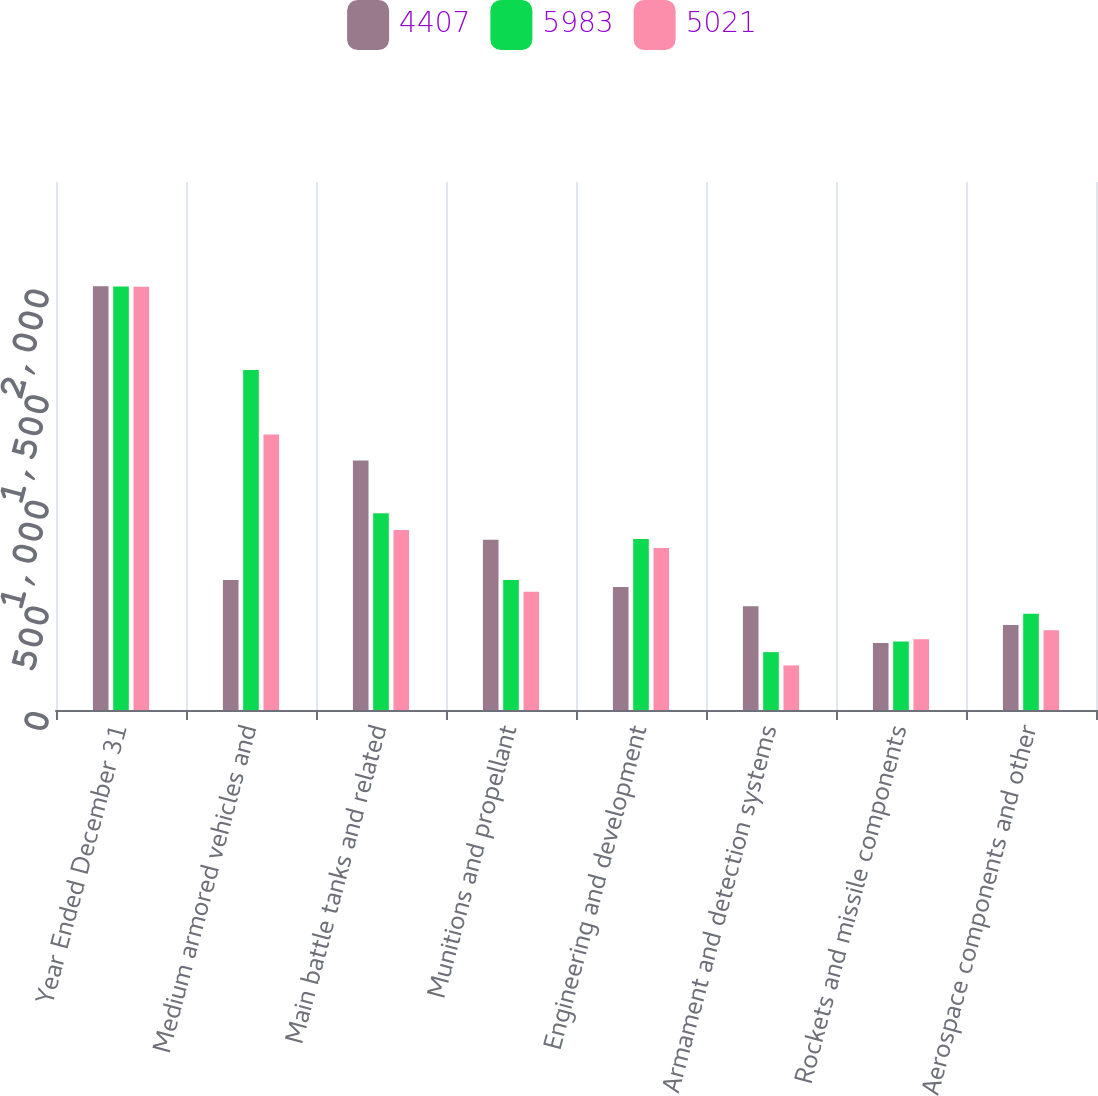Convert chart. <chart><loc_0><loc_0><loc_500><loc_500><stacked_bar_chart><ecel><fcel>Year Ended December 31<fcel>Medium armored vehicles and<fcel>Main battle tanks and related<fcel>Munitions and propellant<fcel>Engineering and development<fcel>Armament and detection systems<fcel>Rockets and missile components<fcel>Aerospace components and other<nl><fcel>4407<fcel>2006<fcel>616<fcel>1181<fcel>806<fcel>582<fcel>491<fcel>317<fcel>402<nl><fcel>5983<fcel>2005<fcel>1610<fcel>931<fcel>616<fcel>810<fcel>274<fcel>324<fcel>456<nl><fcel>5021<fcel>2004<fcel>1304<fcel>852<fcel>560<fcel>767<fcel>211<fcel>335<fcel>378<nl></chart> 